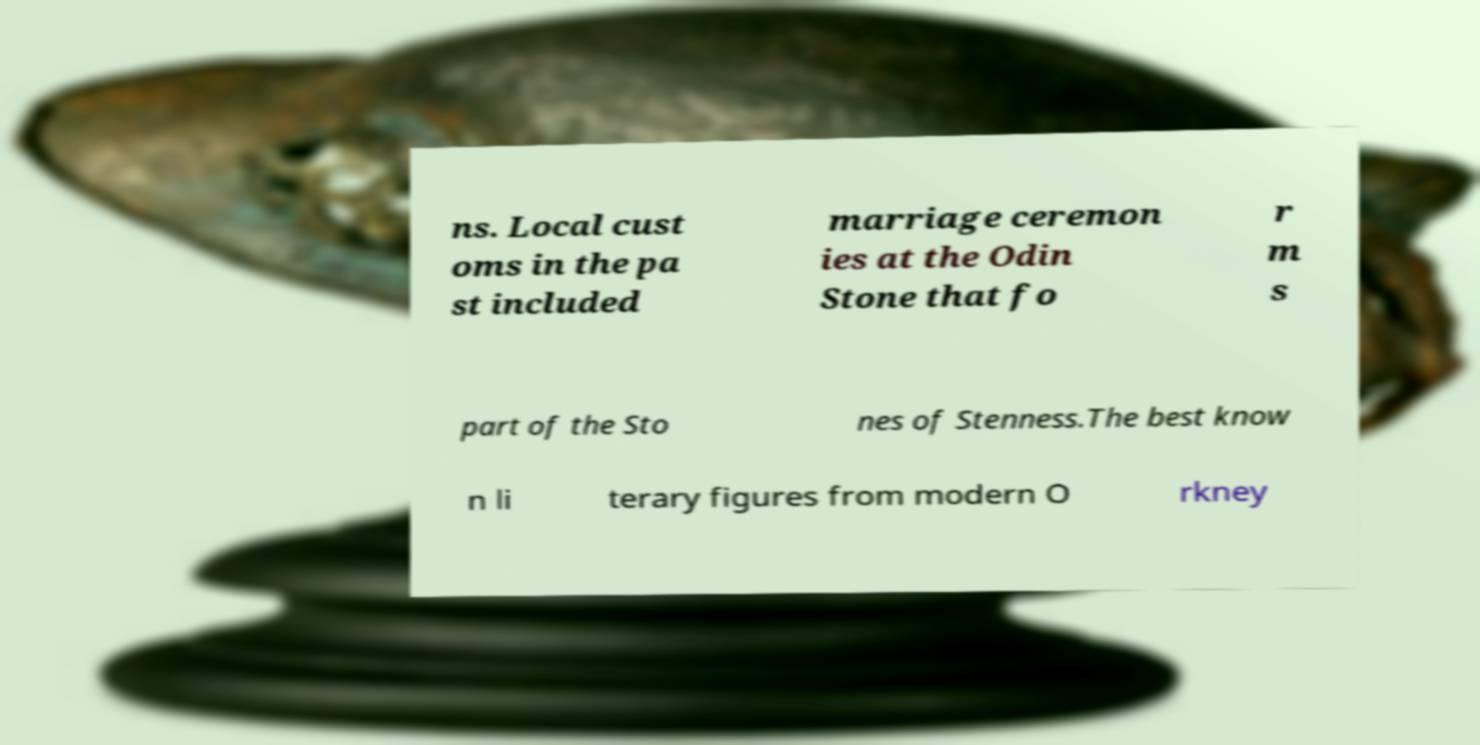Can you accurately transcribe the text from the provided image for me? ns. Local cust oms in the pa st included marriage ceremon ies at the Odin Stone that fo r m s part of the Sto nes of Stenness.The best know n li terary figures from modern O rkney 